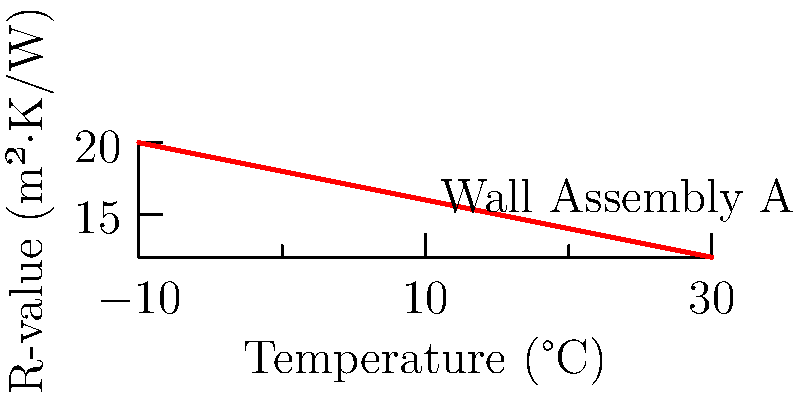Given the graph showing the relationship between temperature and R-value for Wall Assembly A, calculate the U-value of the wall assembly at 20°C. Assume the wall thickness is 0.3 meters. To solve this problem, we'll follow these steps:

1. Determine the R-value at 20°C from the graph:
   At 20°C, the R-value is approximately 14 m²·K/W.

2. Calculate the U-value using the formula:
   $$U = \frac{1}{R}$$
   Where:
   U = U-value (W/m²·K)
   R = R-value (m²·K/W)

3. Substitute the R-value into the formula:
   $$U = \frac{1}{14} = 0.0714 \text{ W/m²·K}$$

4. Convert the U-value to W/m·K by multiplying by the wall thickness:
   $$U_{wall} = 0.0714 \text{ W/m²·K} \times 0.3 \text{ m} = 0.0214 \text{ W/m·K}$$

The U-value of Wall Assembly A at 20°C is 0.0214 W/m·K.
Answer: 0.0214 W/m·K 